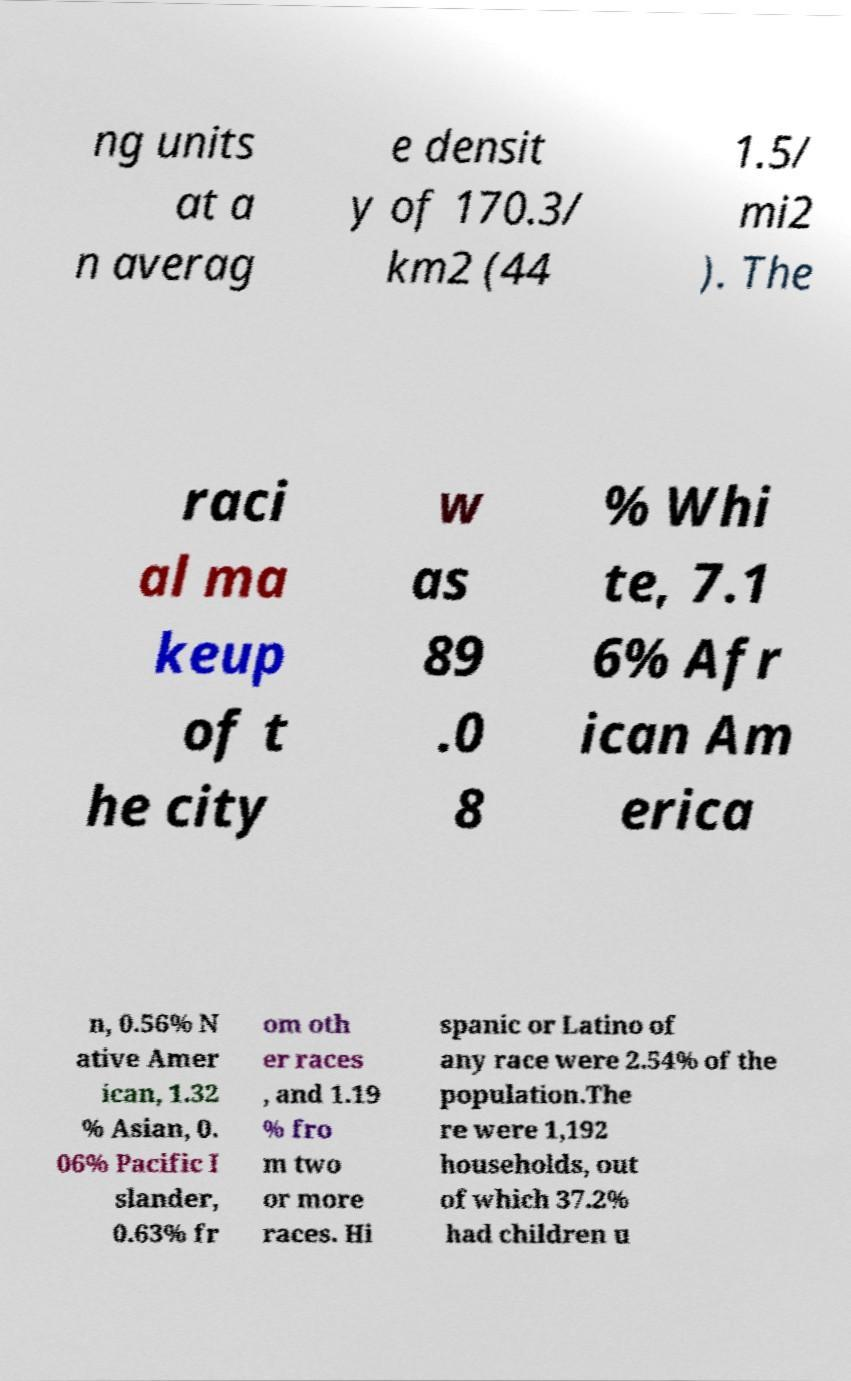Please read and relay the text visible in this image. What does it say? ng units at a n averag e densit y of 170.3/ km2 (44 1.5/ mi2 ). The raci al ma keup of t he city w as 89 .0 8 % Whi te, 7.1 6% Afr ican Am erica n, 0.56% N ative Amer ican, 1.32 % Asian, 0. 06% Pacific I slander, 0.63% fr om oth er races , and 1.19 % fro m two or more races. Hi spanic or Latino of any race were 2.54% of the population.The re were 1,192 households, out of which 37.2% had children u 